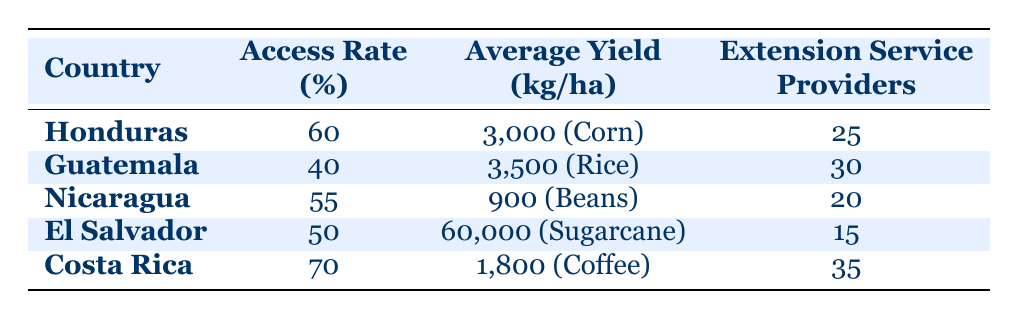What is the access rate for El Salvador? The table shows that El Salvador has an access rate of 50%.
Answer: 50% Which country has the highest average yield? El Salvador has the highest average yield of 60,000 kg per hectare.
Answer: El Salvador How many extension service providers does Guatemala have compared to Honduras? Guatemala has 30 extension service providers, while Honduras has 25. Therefore, Guatemala has 5 more extension service providers than Honduras.
Answer: Guatemala has 5 more Is the average yield for coffee higher than that for corn? The average yield for coffee is 1,800 kg per hectare, while for corn it is 3,000 kg per hectare. Since 1,800 is less than 3,000, the statement is false.
Answer: No What is the average access rate of all countries listed in the table? The access rates are 60, 40, 55, 50, and 70 for Honduras, Guatemala, Nicaragua, El Salvador, and Costa Rica, respectively. The sum is 60 + 40 + 55 + 50 + 70 = 275. There are 5 countries, so the average is 275 / 5 = 55.
Answer: 55 Which country has the lowest average yield, and what is that yield? From the table, Nicaragua has the lowest average yield of 900 kg per hectare for beans.
Answer: Nicaragua, 900 kg/ha Does Costa Rica have a higher access rate than Nicaragua? Costa Rica has an access rate of 70%, while Nicaragua has an access rate of 55%. Since 70 is greater than 55, the statement is true.
Answer: Yes What is the difference in access rates between Honduras and Costa Rica? Honduras has an access rate of 60%, while Costa Rica has 70%. The difference is 70 - 60 = 10 percentage points.
Answer: 10% 